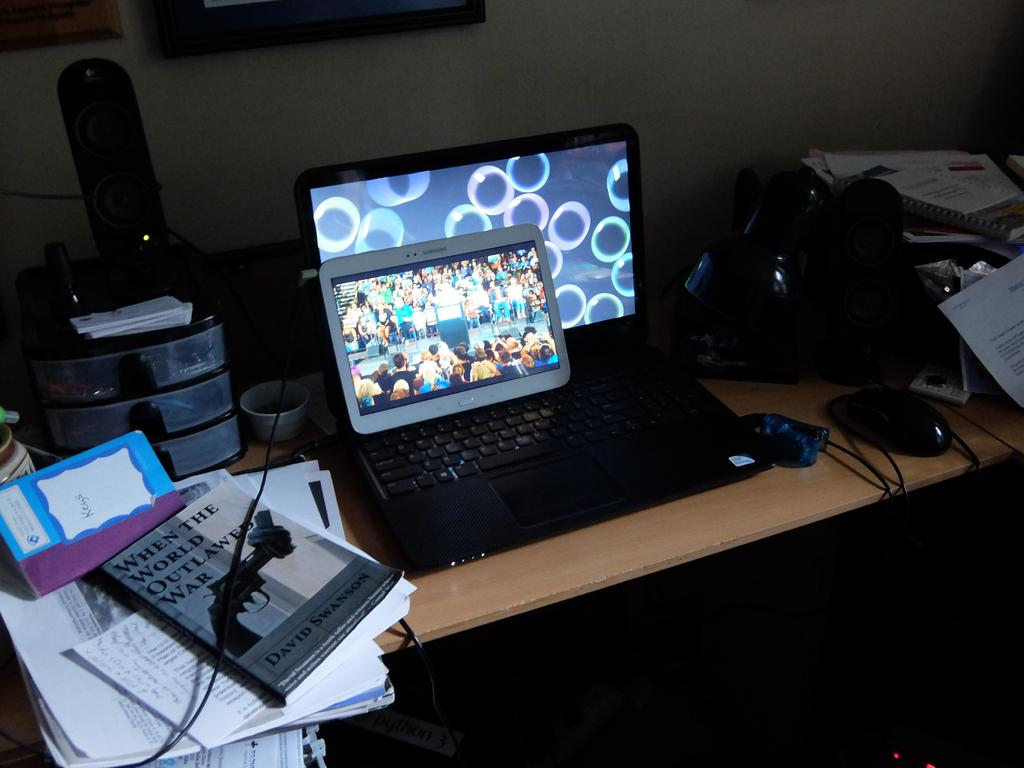<image>
Share a concise interpretation of the image provided. A laptop and tablet on a table next to the book When the World Outlawed War 